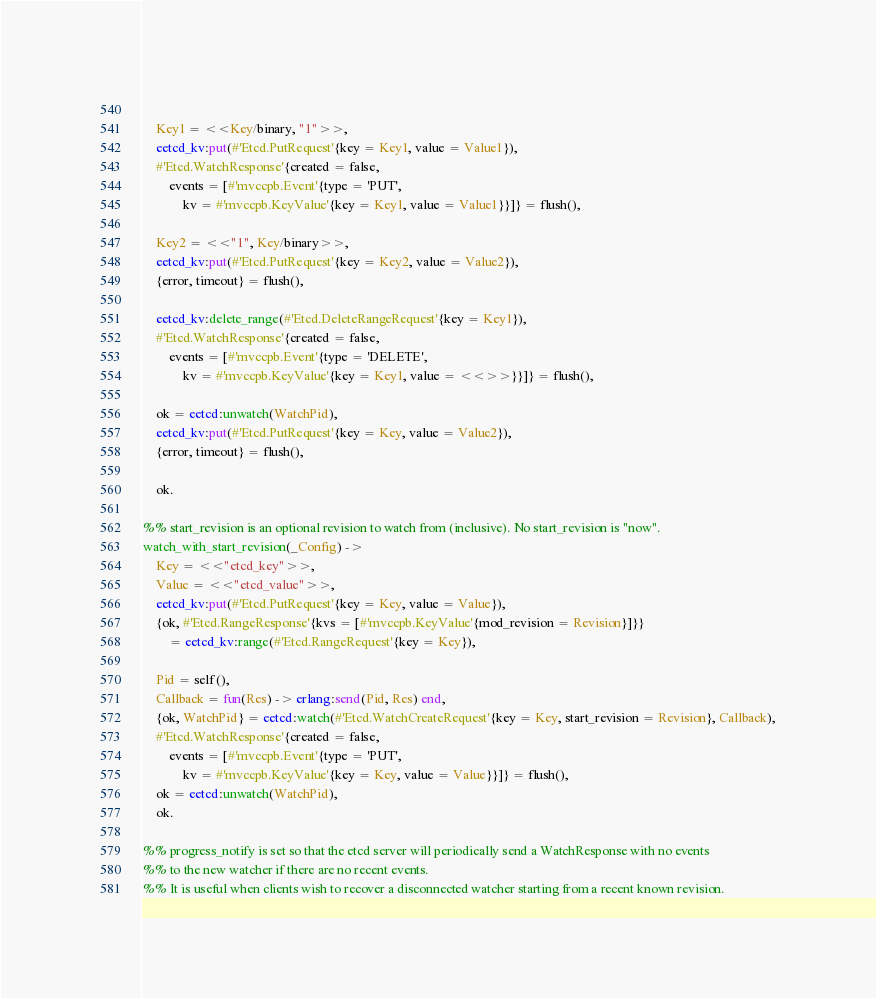<code> <loc_0><loc_0><loc_500><loc_500><_Erlang_>    
    Key1 = <<Key/binary, "1">>,
    eetcd_kv:put(#'Etcd.PutRequest'{key = Key1, value = Value1}),
    #'Etcd.WatchResponse'{created = false,
        events = [#'mvccpb.Event'{type = 'PUT',
            kv = #'mvccpb.KeyValue'{key = Key1, value = Value1}}]} = flush(),
    
    Key2 = <<"1", Key/binary>>,
    eetcd_kv:put(#'Etcd.PutRequest'{key = Key2, value = Value2}),
    {error, timeout} = flush(),
    
    eetcd_kv:delete_range(#'Etcd.DeleteRangeRequest'{key = Key1}),
    #'Etcd.WatchResponse'{created = false,
        events = [#'mvccpb.Event'{type = 'DELETE',
            kv = #'mvccpb.KeyValue'{key = Key1, value = <<>>}}]} = flush(),
    
    ok = eetcd:unwatch(WatchPid),
    eetcd_kv:put(#'Etcd.PutRequest'{key = Key, value = Value2}),
    {error, timeout} = flush(),
    
    ok.

%% start_revision is an optional revision to watch from (inclusive). No start_revision is "now".
watch_with_start_revision(_Config) ->
    Key = <<"etcd_key">>,
    Value = <<"etcd_value">>,
    eetcd_kv:put(#'Etcd.PutRequest'{key = Key, value = Value}),
    {ok, #'Etcd.RangeResponse'{kvs = [#'mvccpb.KeyValue'{mod_revision = Revision}]}}
        = eetcd_kv:range(#'Etcd.RangeRequest'{key = Key}),
    
    Pid = self(),
    Callback = fun(Res) -> erlang:send(Pid, Res) end,
    {ok, WatchPid} = eetcd:watch(#'Etcd.WatchCreateRequest'{key = Key, start_revision = Revision}, Callback),
    #'Etcd.WatchResponse'{created = false,
        events = [#'mvccpb.Event'{type = 'PUT',
            kv = #'mvccpb.KeyValue'{key = Key, value = Value}}]} = flush(),
    ok = eetcd:unwatch(WatchPid),
    ok.

%% progress_notify is set so that the etcd server will periodically send a WatchResponse with no events
%% to the new watcher if there are no recent events.
%% It is useful when clients wish to recover a disconnected watcher starting from a recent known revision.</code> 